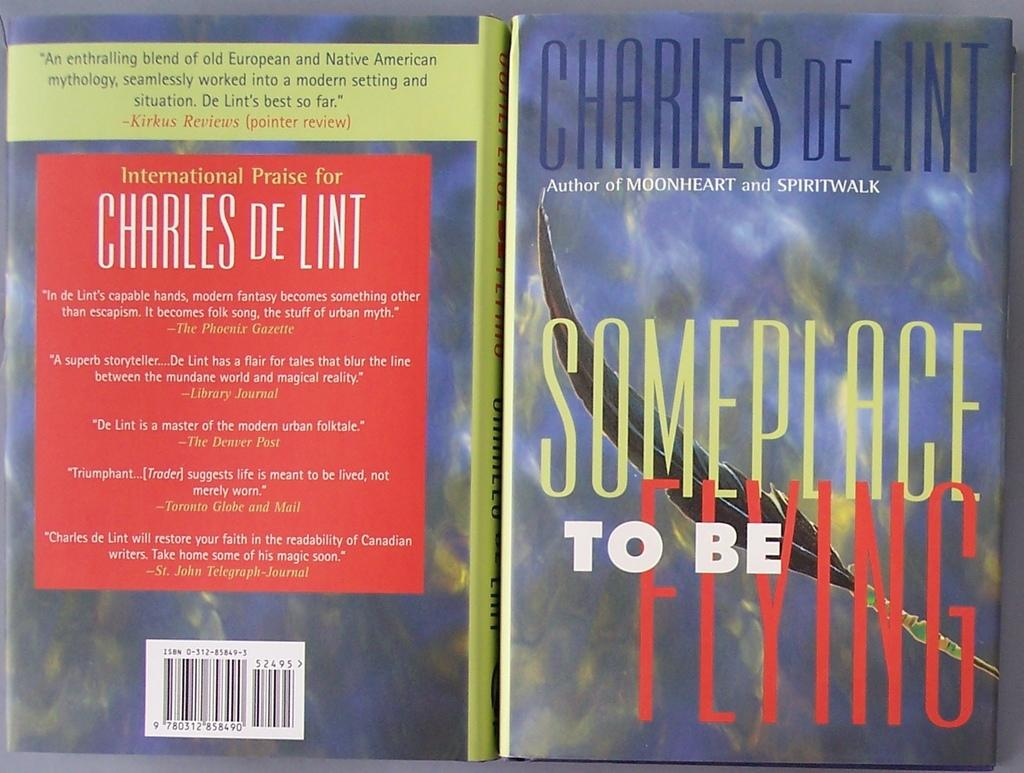<image>
Render a clear and concise summary of the photo. A book by Charles De Lint called Someplace To Be Flying 